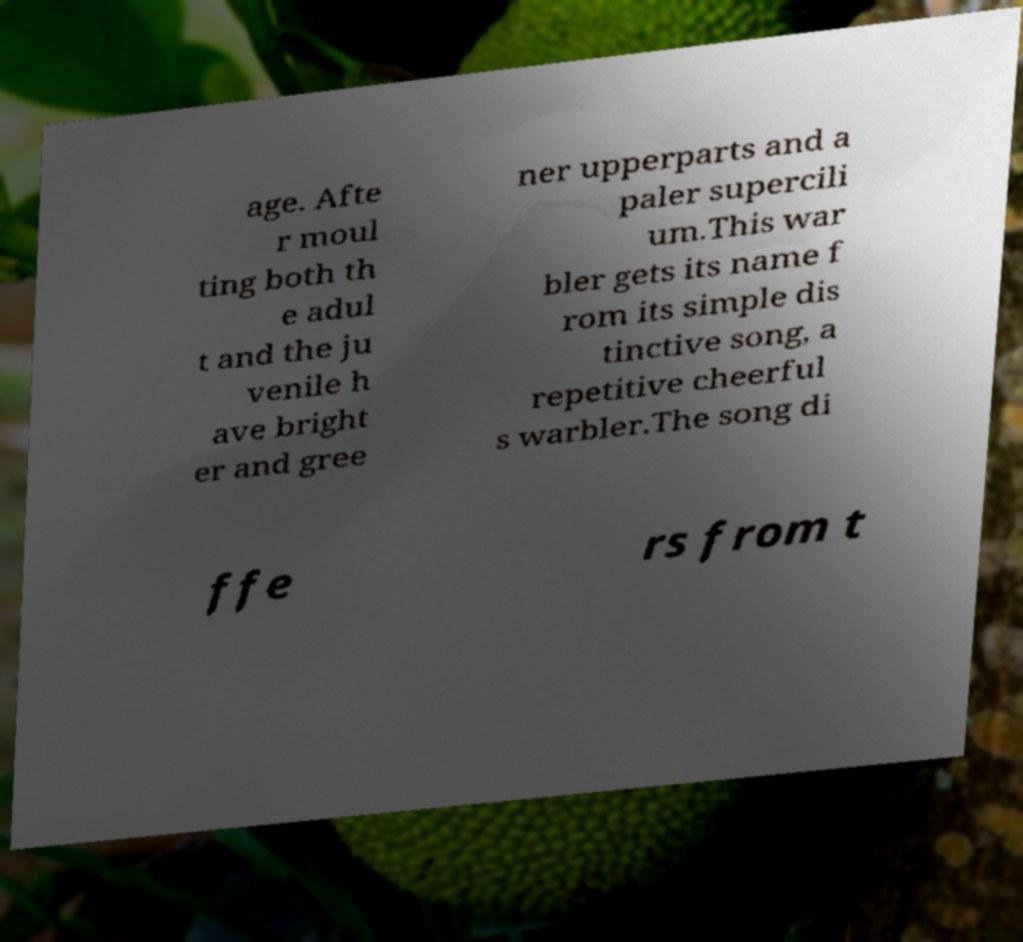I need the written content from this picture converted into text. Can you do that? age. Afte r moul ting both th e adul t and the ju venile h ave bright er and gree ner upperparts and a paler supercili um.This war bler gets its name f rom its simple dis tinctive song, a repetitive cheerful s warbler.The song di ffe rs from t 